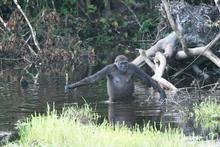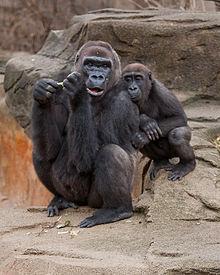The first image is the image on the left, the second image is the image on the right. For the images displayed, is the sentence "An image shows a baby gorilla held in its mother's arms." factually correct? Answer yes or no. No. The first image is the image on the left, the second image is the image on the right. Analyze the images presented: Is the assertion "A gorilla is holding a baby in one of the images." valid? Answer yes or no. No. 